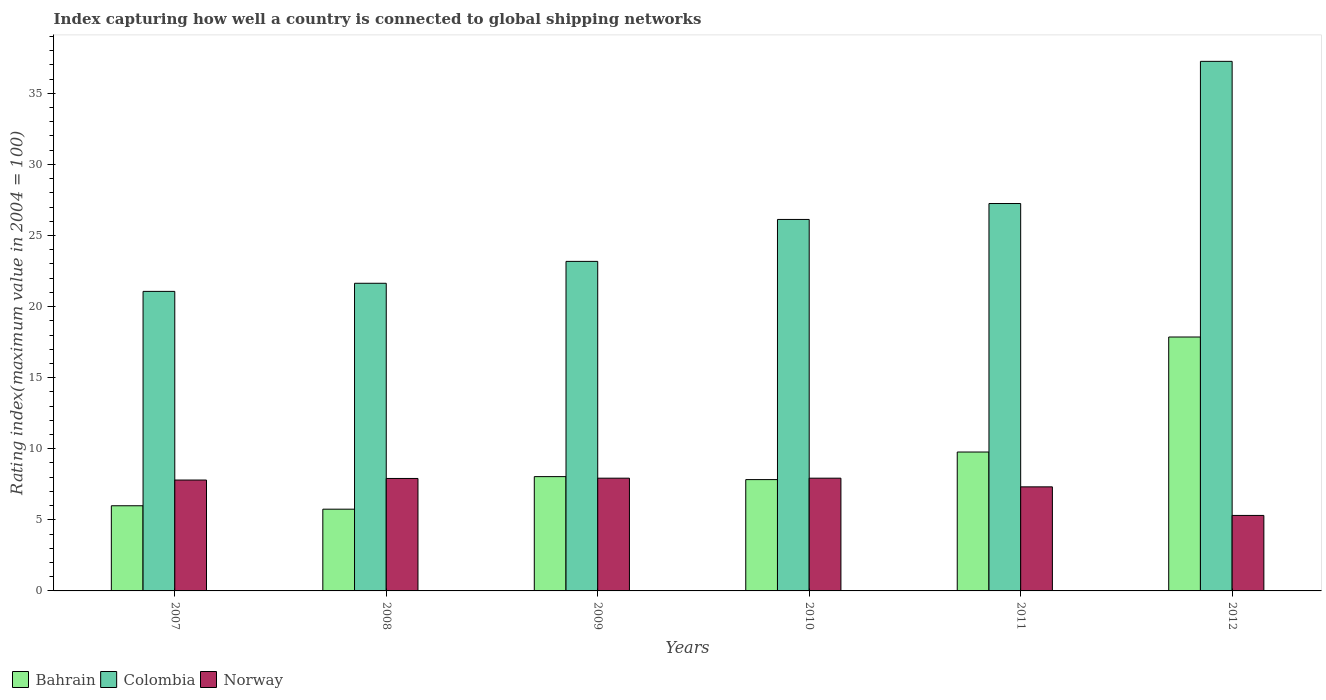How many groups of bars are there?
Your answer should be very brief. 6. Are the number of bars on each tick of the X-axis equal?
Make the answer very short. Yes. How many bars are there on the 3rd tick from the right?
Make the answer very short. 3. What is the label of the 5th group of bars from the left?
Give a very brief answer. 2011. In how many cases, is the number of bars for a given year not equal to the number of legend labels?
Offer a terse response. 0. What is the rating index in Bahrain in 2007?
Keep it short and to the point. 5.99. Across all years, what is the maximum rating index in Bahrain?
Ensure brevity in your answer.  17.86. Across all years, what is the minimum rating index in Bahrain?
Your response must be concise. 5.75. In which year was the rating index in Colombia minimum?
Keep it short and to the point. 2007. What is the total rating index in Colombia in the graph?
Your answer should be compact. 156.52. What is the difference between the rating index in Norway in 2009 and that in 2012?
Your answer should be very brief. 2.62. What is the difference between the rating index in Bahrain in 2007 and the rating index in Norway in 2012?
Your response must be concise. 0.68. What is the average rating index in Colombia per year?
Ensure brevity in your answer.  26.09. In the year 2009, what is the difference between the rating index in Colombia and rating index in Bahrain?
Your answer should be very brief. 15.14. In how many years, is the rating index in Colombia greater than 24?
Provide a short and direct response. 3. What is the ratio of the rating index in Colombia in 2010 to that in 2011?
Make the answer very short. 0.96. Is the rating index in Colombia in 2007 less than that in 2012?
Ensure brevity in your answer.  Yes. What is the difference between the highest and the second highest rating index in Norway?
Ensure brevity in your answer.  0. What is the difference between the highest and the lowest rating index in Colombia?
Give a very brief answer. 16.18. In how many years, is the rating index in Colombia greater than the average rating index in Colombia taken over all years?
Offer a very short reply. 3. Is the sum of the rating index in Colombia in 2008 and 2012 greater than the maximum rating index in Norway across all years?
Your answer should be compact. Yes. How many years are there in the graph?
Your response must be concise. 6. What is the difference between two consecutive major ticks on the Y-axis?
Give a very brief answer. 5. Does the graph contain any zero values?
Your response must be concise. No. Where does the legend appear in the graph?
Provide a short and direct response. Bottom left. What is the title of the graph?
Your response must be concise. Index capturing how well a country is connected to global shipping networks. What is the label or title of the Y-axis?
Give a very brief answer. Rating index(maximum value in 2004 = 100). What is the Rating index(maximum value in 2004 = 100) of Bahrain in 2007?
Make the answer very short. 5.99. What is the Rating index(maximum value in 2004 = 100) of Colombia in 2007?
Offer a terse response. 21.07. What is the Rating index(maximum value in 2004 = 100) in Norway in 2007?
Keep it short and to the point. 7.8. What is the Rating index(maximum value in 2004 = 100) of Bahrain in 2008?
Give a very brief answer. 5.75. What is the Rating index(maximum value in 2004 = 100) of Colombia in 2008?
Offer a very short reply. 21.64. What is the Rating index(maximum value in 2004 = 100) of Norway in 2008?
Keep it short and to the point. 7.91. What is the Rating index(maximum value in 2004 = 100) of Bahrain in 2009?
Give a very brief answer. 8.04. What is the Rating index(maximum value in 2004 = 100) of Colombia in 2009?
Offer a terse response. 23.18. What is the Rating index(maximum value in 2004 = 100) of Norway in 2009?
Your response must be concise. 7.93. What is the Rating index(maximum value in 2004 = 100) of Bahrain in 2010?
Your response must be concise. 7.83. What is the Rating index(maximum value in 2004 = 100) of Colombia in 2010?
Provide a short and direct response. 26.13. What is the Rating index(maximum value in 2004 = 100) of Norway in 2010?
Your response must be concise. 7.93. What is the Rating index(maximum value in 2004 = 100) in Bahrain in 2011?
Ensure brevity in your answer.  9.77. What is the Rating index(maximum value in 2004 = 100) in Colombia in 2011?
Your answer should be compact. 27.25. What is the Rating index(maximum value in 2004 = 100) in Norway in 2011?
Keep it short and to the point. 7.32. What is the Rating index(maximum value in 2004 = 100) in Bahrain in 2012?
Provide a short and direct response. 17.86. What is the Rating index(maximum value in 2004 = 100) of Colombia in 2012?
Your response must be concise. 37.25. What is the Rating index(maximum value in 2004 = 100) in Norway in 2012?
Your answer should be compact. 5.31. Across all years, what is the maximum Rating index(maximum value in 2004 = 100) of Bahrain?
Your answer should be very brief. 17.86. Across all years, what is the maximum Rating index(maximum value in 2004 = 100) in Colombia?
Your answer should be very brief. 37.25. Across all years, what is the maximum Rating index(maximum value in 2004 = 100) in Norway?
Provide a short and direct response. 7.93. Across all years, what is the minimum Rating index(maximum value in 2004 = 100) in Bahrain?
Your response must be concise. 5.75. Across all years, what is the minimum Rating index(maximum value in 2004 = 100) in Colombia?
Make the answer very short. 21.07. Across all years, what is the minimum Rating index(maximum value in 2004 = 100) in Norway?
Give a very brief answer. 5.31. What is the total Rating index(maximum value in 2004 = 100) of Bahrain in the graph?
Your answer should be very brief. 55.24. What is the total Rating index(maximum value in 2004 = 100) of Colombia in the graph?
Provide a short and direct response. 156.52. What is the total Rating index(maximum value in 2004 = 100) of Norway in the graph?
Offer a terse response. 44.2. What is the difference between the Rating index(maximum value in 2004 = 100) of Bahrain in 2007 and that in 2008?
Keep it short and to the point. 0.24. What is the difference between the Rating index(maximum value in 2004 = 100) of Colombia in 2007 and that in 2008?
Ensure brevity in your answer.  -0.57. What is the difference between the Rating index(maximum value in 2004 = 100) in Norway in 2007 and that in 2008?
Provide a short and direct response. -0.11. What is the difference between the Rating index(maximum value in 2004 = 100) in Bahrain in 2007 and that in 2009?
Make the answer very short. -2.05. What is the difference between the Rating index(maximum value in 2004 = 100) in Colombia in 2007 and that in 2009?
Ensure brevity in your answer.  -2.11. What is the difference between the Rating index(maximum value in 2004 = 100) in Norway in 2007 and that in 2009?
Provide a short and direct response. -0.13. What is the difference between the Rating index(maximum value in 2004 = 100) in Bahrain in 2007 and that in 2010?
Your response must be concise. -1.84. What is the difference between the Rating index(maximum value in 2004 = 100) in Colombia in 2007 and that in 2010?
Offer a terse response. -5.06. What is the difference between the Rating index(maximum value in 2004 = 100) of Norway in 2007 and that in 2010?
Keep it short and to the point. -0.13. What is the difference between the Rating index(maximum value in 2004 = 100) in Bahrain in 2007 and that in 2011?
Provide a succinct answer. -3.78. What is the difference between the Rating index(maximum value in 2004 = 100) in Colombia in 2007 and that in 2011?
Keep it short and to the point. -6.18. What is the difference between the Rating index(maximum value in 2004 = 100) in Norway in 2007 and that in 2011?
Provide a short and direct response. 0.48. What is the difference between the Rating index(maximum value in 2004 = 100) of Bahrain in 2007 and that in 2012?
Give a very brief answer. -11.87. What is the difference between the Rating index(maximum value in 2004 = 100) in Colombia in 2007 and that in 2012?
Provide a succinct answer. -16.18. What is the difference between the Rating index(maximum value in 2004 = 100) in Norway in 2007 and that in 2012?
Your answer should be compact. 2.49. What is the difference between the Rating index(maximum value in 2004 = 100) in Bahrain in 2008 and that in 2009?
Your answer should be compact. -2.29. What is the difference between the Rating index(maximum value in 2004 = 100) of Colombia in 2008 and that in 2009?
Provide a short and direct response. -1.54. What is the difference between the Rating index(maximum value in 2004 = 100) of Norway in 2008 and that in 2009?
Your answer should be very brief. -0.02. What is the difference between the Rating index(maximum value in 2004 = 100) in Bahrain in 2008 and that in 2010?
Provide a succinct answer. -2.08. What is the difference between the Rating index(maximum value in 2004 = 100) in Colombia in 2008 and that in 2010?
Give a very brief answer. -4.49. What is the difference between the Rating index(maximum value in 2004 = 100) in Norway in 2008 and that in 2010?
Your answer should be very brief. -0.02. What is the difference between the Rating index(maximum value in 2004 = 100) in Bahrain in 2008 and that in 2011?
Make the answer very short. -4.02. What is the difference between the Rating index(maximum value in 2004 = 100) in Colombia in 2008 and that in 2011?
Your answer should be compact. -5.61. What is the difference between the Rating index(maximum value in 2004 = 100) of Norway in 2008 and that in 2011?
Keep it short and to the point. 0.59. What is the difference between the Rating index(maximum value in 2004 = 100) of Bahrain in 2008 and that in 2012?
Offer a terse response. -12.11. What is the difference between the Rating index(maximum value in 2004 = 100) in Colombia in 2008 and that in 2012?
Your answer should be very brief. -15.61. What is the difference between the Rating index(maximum value in 2004 = 100) of Norway in 2008 and that in 2012?
Provide a succinct answer. 2.6. What is the difference between the Rating index(maximum value in 2004 = 100) in Bahrain in 2009 and that in 2010?
Offer a very short reply. 0.21. What is the difference between the Rating index(maximum value in 2004 = 100) in Colombia in 2009 and that in 2010?
Provide a short and direct response. -2.95. What is the difference between the Rating index(maximum value in 2004 = 100) in Bahrain in 2009 and that in 2011?
Provide a succinct answer. -1.73. What is the difference between the Rating index(maximum value in 2004 = 100) in Colombia in 2009 and that in 2011?
Your answer should be compact. -4.07. What is the difference between the Rating index(maximum value in 2004 = 100) of Norway in 2009 and that in 2011?
Offer a very short reply. 0.61. What is the difference between the Rating index(maximum value in 2004 = 100) of Bahrain in 2009 and that in 2012?
Ensure brevity in your answer.  -9.82. What is the difference between the Rating index(maximum value in 2004 = 100) of Colombia in 2009 and that in 2012?
Provide a succinct answer. -14.07. What is the difference between the Rating index(maximum value in 2004 = 100) in Norway in 2009 and that in 2012?
Offer a very short reply. 2.62. What is the difference between the Rating index(maximum value in 2004 = 100) of Bahrain in 2010 and that in 2011?
Your answer should be very brief. -1.94. What is the difference between the Rating index(maximum value in 2004 = 100) of Colombia in 2010 and that in 2011?
Provide a short and direct response. -1.12. What is the difference between the Rating index(maximum value in 2004 = 100) in Norway in 2010 and that in 2011?
Offer a very short reply. 0.61. What is the difference between the Rating index(maximum value in 2004 = 100) of Bahrain in 2010 and that in 2012?
Your answer should be very brief. -10.03. What is the difference between the Rating index(maximum value in 2004 = 100) in Colombia in 2010 and that in 2012?
Provide a short and direct response. -11.12. What is the difference between the Rating index(maximum value in 2004 = 100) of Norway in 2010 and that in 2012?
Make the answer very short. 2.62. What is the difference between the Rating index(maximum value in 2004 = 100) in Bahrain in 2011 and that in 2012?
Make the answer very short. -8.09. What is the difference between the Rating index(maximum value in 2004 = 100) of Colombia in 2011 and that in 2012?
Ensure brevity in your answer.  -10. What is the difference between the Rating index(maximum value in 2004 = 100) of Norway in 2011 and that in 2012?
Make the answer very short. 2.01. What is the difference between the Rating index(maximum value in 2004 = 100) of Bahrain in 2007 and the Rating index(maximum value in 2004 = 100) of Colombia in 2008?
Your answer should be very brief. -15.65. What is the difference between the Rating index(maximum value in 2004 = 100) of Bahrain in 2007 and the Rating index(maximum value in 2004 = 100) of Norway in 2008?
Provide a short and direct response. -1.92. What is the difference between the Rating index(maximum value in 2004 = 100) of Colombia in 2007 and the Rating index(maximum value in 2004 = 100) of Norway in 2008?
Your answer should be compact. 13.16. What is the difference between the Rating index(maximum value in 2004 = 100) in Bahrain in 2007 and the Rating index(maximum value in 2004 = 100) in Colombia in 2009?
Your answer should be compact. -17.19. What is the difference between the Rating index(maximum value in 2004 = 100) of Bahrain in 2007 and the Rating index(maximum value in 2004 = 100) of Norway in 2009?
Ensure brevity in your answer.  -1.94. What is the difference between the Rating index(maximum value in 2004 = 100) of Colombia in 2007 and the Rating index(maximum value in 2004 = 100) of Norway in 2009?
Your answer should be compact. 13.14. What is the difference between the Rating index(maximum value in 2004 = 100) in Bahrain in 2007 and the Rating index(maximum value in 2004 = 100) in Colombia in 2010?
Offer a terse response. -20.14. What is the difference between the Rating index(maximum value in 2004 = 100) in Bahrain in 2007 and the Rating index(maximum value in 2004 = 100) in Norway in 2010?
Your answer should be compact. -1.94. What is the difference between the Rating index(maximum value in 2004 = 100) of Colombia in 2007 and the Rating index(maximum value in 2004 = 100) of Norway in 2010?
Provide a succinct answer. 13.14. What is the difference between the Rating index(maximum value in 2004 = 100) of Bahrain in 2007 and the Rating index(maximum value in 2004 = 100) of Colombia in 2011?
Keep it short and to the point. -21.26. What is the difference between the Rating index(maximum value in 2004 = 100) of Bahrain in 2007 and the Rating index(maximum value in 2004 = 100) of Norway in 2011?
Ensure brevity in your answer.  -1.33. What is the difference between the Rating index(maximum value in 2004 = 100) in Colombia in 2007 and the Rating index(maximum value in 2004 = 100) in Norway in 2011?
Your answer should be compact. 13.75. What is the difference between the Rating index(maximum value in 2004 = 100) of Bahrain in 2007 and the Rating index(maximum value in 2004 = 100) of Colombia in 2012?
Offer a very short reply. -31.26. What is the difference between the Rating index(maximum value in 2004 = 100) of Bahrain in 2007 and the Rating index(maximum value in 2004 = 100) of Norway in 2012?
Your answer should be compact. 0.68. What is the difference between the Rating index(maximum value in 2004 = 100) in Colombia in 2007 and the Rating index(maximum value in 2004 = 100) in Norway in 2012?
Your answer should be very brief. 15.76. What is the difference between the Rating index(maximum value in 2004 = 100) in Bahrain in 2008 and the Rating index(maximum value in 2004 = 100) in Colombia in 2009?
Provide a short and direct response. -17.43. What is the difference between the Rating index(maximum value in 2004 = 100) in Bahrain in 2008 and the Rating index(maximum value in 2004 = 100) in Norway in 2009?
Provide a short and direct response. -2.18. What is the difference between the Rating index(maximum value in 2004 = 100) of Colombia in 2008 and the Rating index(maximum value in 2004 = 100) of Norway in 2009?
Offer a terse response. 13.71. What is the difference between the Rating index(maximum value in 2004 = 100) in Bahrain in 2008 and the Rating index(maximum value in 2004 = 100) in Colombia in 2010?
Offer a terse response. -20.38. What is the difference between the Rating index(maximum value in 2004 = 100) in Bahrain in 2008 and the Rating index(maximum value in 2004 = 100) in Norway in 2010?
Offer a terse response. -2.18. What is the difference between the Rating index(maximum value in 2004 = 100) of Colombia in 2008 and the Rating index(maximum value in 2004 = 100) of Norway in 2010?
Your response must be concise. 13.71. What is the difference between the Rating index(maximum value in 2004 = 100) in Bahrain in 2008 and the Rating index(maximum value in 2004 = 100) in Colombia in 2011?
Keep it short and to the point. -21.5. What is the difference between the Rating index(maximum value in 2004 = 100) of Bahrain in 2008 and the Rating index(maximum value in 2004 = 100) of Norway in 2011?
Your answer should be compact. -1.57. What is the difference between the Rating index(maximum value in 2004 = 100) of Colombia in 2008 and the Rating index(maximum value in 2004 = 100) of Norway in 2011?
Provide a succinct answer. 14.32. What is the difference between the Rating index(maximum value in 2004 = 100) in Bahrain in 2008 and the Rating index(maximum value in 2004 = 100) in Colombia in 2012?
Give a very brief answer. -31.5. What is the difference between the Rating index(maximum value in 2004 = 100) in Bahrain in 2008 and the Rating index(maximum value in 2004 = 100) in Norway in 2012?
Offer a terse response. 0.44. What is the difference between the Rating index(maximum value in 2004 = 100) in Colombia in 2008 and the Rating index(maximum value in 2004 = 100) in Norway in 2012?
Make the answer very short. 16.33. What is the difference between the Rating index(maximum value in 2004 = 100) in Bahrain in 2009 and the Rating index(maximum value in 2004 = 100) in Colombia in 2010?
Make the answer very short. -18.09. What is the difference between the Rating index(maximum value in 2004 = 100) in Bahrain in 2009 and the Rating index(maximum value in 2004 = 100) in Norway in 2010?
Your answer should be very brief. 0.11. What is the difference between the Rating index(maximum value in 2004 = 100) of Colombia in 2009 and the Rating index(maximum value in 2004 = 100) of Norway in 2010?
Give a very brief answer. 15.25. What is the difference between the Rating index(maximum value in 2004 = 100) in Bahrain in 2009 and the Rating index(maximum value in 2004 = 100) in Colombia in 2011?
Your answer should be compact. -19.21. What is the difference between the Rating index(maximum value in 2004 = 100) in Bahrain in 2009 and the Rating index(maximum value in 2004 = 100) in Norway in 2011?
Offer a very short reply. 0.72. What is the difference between the Rating index(maximum value in 2004 = 100) of Colombia in 2009 and the Rating index(maximum value in 2004 = 100) of Norway in 2011?
Offer a very short reply. 15.86. What is the difference between the Rating index(maximum value in 2004 = 100) of Bahrain in 2009 and the Rating index(maximum value in 2004 = 100) of Colombia in 2012?
Give a very brief answer. -29.21. What is the difference between the Rating index(maximum value in 2004 = 100) of Bahrain in 2009 and the Rating index(maximum value in 2004 = 100) of Norway in 2012?
Give a very brief answer. 2.73. What is the difference between the Rating index(maximum value in 2004 = 100) of Colombia in 2009 and the Rating index(maximum value in 2004 = 100) of Norway in 2012?
Offer a terse response. 17.87. What is the difference between the Rating index(maximum value in 2004 = 100) of Bahrain in 2010 and the Rating index(maximum value in 2004 = 100) of Colombia in 2011?
Keep it short and to the point. -19.42. What is the difference between the Rating index(maximum value in 2004 = 100) of Bahrain in 2010 and the Rating index(maximum value in 2004 = 100) of Norway in 2011?
Offer a very short reply. 0.51. What is the difference between the Rating index(maximum value in 2004 = 100) of Colombia in 2010 and the Rating index(maximum value in 2004 = 100) of Norway in 2011?
Ensure brevity in your answer.  18.81. What is the difference between the Rating index(maximum value in 2004 = 100) in Bahrain in 2010 and the Rating index(maximum value in 2004 = 100) in Colombia in 2012?
Keep it short and to the point. -29.42. What is the difference between the Rating index(maximum value in 2004 = 100) in Bahrain in 2010 and the Rating index(maximum value in 2004 = 100) in Norway in 2012?
Give a very brief answer. 2.52. What is the difference between the Rating index(maximum value in 2004 = 100) of Colombia in 2010 and the Rating index(maximum value in 2004 = 100) of Norway in 2012?
Make the answer very short. 20.82. What is the difference between the Rating index(maximum value in 2004 = 100) in Bahrain in 2011 and the Rating index(maximum value in 2004 = 100) in Colombia in 2012?
Provide a succinct answer. -27.48. What is the difference between the Rating index(maximum value in 2004 = 100) in Bahrain in 2011 and the Rating index(maximum value in 2004 = 100) in Norway in 2012?
Make the answer very short. 4.46. What is the difference between the Rating index(maximum value in 2004 = 100) in Colombia in 2011 and the Rating index(maximum value in 2004 = 100) in Norway in 2012?
Give a very brief answer. 21.94. What is the average Rating index(maximum value in 2004 = 100) in Bahrain per year?
Your answer should be compact. 9.21. What is the average Rating index(maximum value in 2004 = 100) of Colombia per year?
Give a very brief answer. 26.09. What is the average Rating index(maximum value in 2004 = 100) in Norway per year?
Give a very brief answer. 7.37. In the year 2007, what is the difference between the Rating index(maximum value in 2004 = 100) of Bahrain and Rating index(maximum value in 2004 = 100) of Colombia?
Offer a terse response. -15.08. In the year 2007, what is the difference between the Rating index(maximum value in 2004 = 100) in Bahrain and Rating index(maximum value in 2004 = 100) in Norway?
Your answer should be compact. -1.81. In the year 2007, what is the difference between the Rating index(maximum value in 2004 = 100) in Colombia and Rating index(maximum value in 2004 = 100) in Norway?
Provide a succinct answer. 13.27. In the year 2008, what is the difference between the Rating index(maximum value in 2004 = 100) of Bahrain and Rating index(maximum value in 2004 = 100) of Colombia?
Your answer should be very brief. -15.89. In the year 2008, what is the difference between the Rating index(maximum value in 2004 = 100) of Bahrain and Rating index(maximum value in 2004 = 100) of Norway?
Your answer should be compact. -2.16. In the year 2008, what is the difference between the Rating index(maximum value in 2004 = 100) of Colombia and Rating index(maximum value in 2004 = 100) of Norway?
Provide a succinct answer. 13.73. In the year 2009, what is the difference between the Rating index(maximum value in 2004 = 100) of Bahrain and Rating index(maximum value in 2004 = 100) of Colombia?
Make the answer very short. -15.14. In the year 2009, what is the difference between the Rating index(maximum value in 2004 = 100) in Bahrain and Rating index(maximum value in 2004 = 100) in Norway?
Provide a short and direct response. 0.11. In the year 2009, what is the difference between the Rating index(maximum value in 2004 = 100) in Colombia and Rating index(maximum value in 2004 = 100) in Norway?
Your answer should be very brief. 15.25. In the year 2010, what is the difference between the Rating index(maximum value in 2004 = 100) in Bahrain and Rating index(maximum value in 2004 = 100) in Colombia?
Your response must be concise. -18.3. In the year 2010, what is the difference between the Rating index(maximum value in 2004 = 100) in Bahrain and Rating index(maximum value in 2004 = 100) in Norway?
Keep it short and to the point. -0.1. In the year 2010, what is the difference between the Rating index(maximum value in 2004 = 100) of Colombia and Rating index(maximum value in 2004 = 100) of Norway?
Your answer should be very brief. 18.2. In the year 2011, what is the difference between the Rating index(maximum value in 2004 = 100) of Bahrain and Rating index(maximum value in 2004 = 100) of Colombia?
Ensure brevity in your answer.  -17.48. In the year 2011, what is the difference between the Rating index(maximum value in 2004 = 100) in Bahrain and Rating index(maximum value in 2004 = 100) in Norway?
Provide a succinct answer. 2.45. In the year 2011, what is the difference between the Rating index(maximum value in 2004 = 100) in Colombia and Rating index(maximum value in 2004 = 100) in Norway?
Offer a very short reply. 19.93. In the year 2012, what is the difference between the Rating index(maximum value in 2004 = 100) of Bahrain and Rating index(maximum value in 2004 = 100) of Colombia?
Offer a terse response. -19.39. In the year 2012, what is the difference between the Rating index(maximum value in 2004 = 100) of Bahrain and Rating index(maximum value in 2004 = 100) of Norway?
Your response must be concise. 12.55. In the year 2012, what is the difference between the Rating index(maximum value in 2004 = 100) of Colombia and Rating index(maximum value in 2004 = 100) of Norway?
Provide a short and direct response. 31.94. What is the ratio of the Rating index(maximum value in 2004 = 100) in Bahrain in 2007 to that in 2008?
Provide a succinct answer. 1.04. What is the ratio of the Rating index(maximum value in 2004 = 100) of Colombia in 2007 to that in 2008?
Your answer should be very brief. 0.97. What is the ratio of the Rating index(maximum value in 2004 = 100) in Norway in 2007 to that in 2008?
Give a very brief answer. 0.99. What is the ratio of the Rating index(maximum value in 2004 = 100) of Bahrain in 2007 to that in 2009?
Your answer should be compact. 0.74. What is the ratio of the Rating index(maximum value in 2004 = 100) in Colombia in 2007 to that in 2009?
Ensure brevity in your answer.  0.91. What is the ratio of the Rating index(maximum value in 2004 = 100) of Norway in 2007 to that in 2009?
Give a very brief answer. 0.98. What is the ratio of the Rating index(maximum value in 2004 = 100) in Bahrain in 2007 to that in 2010?
Your response must be concise. 0.77. What is the ratio of the Rating index(maximum value in 2004 = 100) of Colombia in 2007 to that in 2010?
Offer a terse response. 0.81. What is the ratio of the Rating index(maximum value in 2004 = 100) of Norway in 2007 to that in 2010?
Provide a short and direct response. 0.98. What is the ratio of the Rating index(maximum value in 2004 = 100) of Bahrain in 2007 to that in 2011?
Ensure brevity in your answer.  0.61. What is the ratio of the Rating index(maximum value in 2004 = 100) of Colombia in 2007 to that in 2011?
Your answer should be compact. 0.77. What is the ratio of the Rating index(maximum value in 2004 = 100) in Norway in 2007 to that in 2011?
Make the answer very short. 1.07. What is the ratio of the Rating index(maximum value in 2004 = 100) in Bahrain in 2007 to that in 2012?
Provide a succinct answer. 0.34. What is the ratio of the Rating index(maximum value in 2004 = 100) in Colombia in 2007 to that in 2012?
Offer a terse response. 0.57. What is the ratio of the Rating index(maximum value in 2004 = 100) of Norway in 2007 to that in 2012?
Your answer should be very brief. 1.47. What is the ratio of the Rating index(maximum value in 2004 = 100) of Bahrain in 2008 to that in 2009?
Your answer should be very brief. 0.72. What is the ratio of the Rating index(maximum value in 2004 = 100) of Colombia in 2008 to that in 2009?
Your answer should be compact. 0.93. What is the ratio of the Rating index(maximum value in 2004 = 100) of Norway in 2008 to that in 2009?
Ensure brevity in your answer.  1. What is the ratio of the Rating index(maximum value in 2004 = 100) in Bahrain in 2008 to that in 2010?
Your response must be concise. 0.73. What is the ratio of the Rating index(maximum value in 2004 = 100) in Colombia in 2008 to that in 2010?
Your response must be concise. 0.83. What is the ratio of the Rating index(maximum value in 2004 = 100) in Norway in 2008 to that in 2010?
Make the answer very short. 1. What is the ratio of the Rating index(maximum value in 2004 = 100) of Bahrain in 2008 to that in 2011?
Give a very brief answer. 0.59. What is the ratio of the Rating index(maximum value in 2004 = 100) in Colombia in 2008 to that in 2011?
Ensure brevity in your answer.  0.79. What is the ratio of the Rating index(maximum value in 2004 = 100) in Norway in 2008 to that in 2011?
Give a very brief answer. 1.08. What is the ratio of the Rating index(maximum value in 2004 = 100) of Bahrain in 2008 to that in 2012?
Ensure brevity in your answer.  0.32. What is the ratio of the Rating index(maximum value in 2004 = 100) in Colombia in 2008 to that in 2012?
Provide a succinct answer. 0.58. What is the ratio of the Rating index(maximum value in 2004 = 100) of Norway in 2008 to that in 2012?
Offer a terse response. 1.49. What is the ratio of the Rating index(maximum value in 2004 = 100) of Bahrain in 2009 to that in 2010?
Your answer should be compact. 1.03. What is the ratio of the Rating index(maximum value in 2004 = 100) of Colombia in 2009 to that in 2010?
Your answer should be compact. 0.89. What is the ratio of the Rating index(maximum value in 2004 = 100) of Norway in 2009 to that in 2010?
Ensure brevity in your answer.  1. What is the ratio of the Rating index(maximum value in 2004 = 100) of Bahrain in 2009 to that in 2011?
Your answer should be compact. 0.82. What is the ratio of the Rating index(maximum value in 2004 = 100) in Colombia in 2009 to that in 2011?
Give a very brief answer. 0.85. What is the ratio of the Rating index(maximum value in 2004 = 100) in Norway in 2009 to that in 2011?
Your answer should be very brief. 1.08. What is the ratio of the Rating index(maximum value in 2004 = 100) of Bahrain in 2009 to that in 2012?
Make the answer very short. 0.45. What is the ratio of the Rating index(maximum value in 2004 = 100) of Colombia in 2009 to that in 2012?
Ensure brevity in your answer.  0.62. What is the ratio of the Rating index(maximum value in 2004 = 100) of Norway in 2009 to that in 2012?
Ensure brevity in your answer.  1.49. What is the ratio of the Rating index(maximum value in 2004 = 100) in Bahrain in 2010 to that in 2011?
Your answer should be compact. 0.8. What is the ratio of the Rating index(maximum value in 2004 = 100) of Colombia in 2010 to that in 2011?
Keep it short and to the point. 0.96. What is the ratio of the Rating index(maximum value in 2004 = 100) in Bahrain in 2010 to that in 2012?
Your answer should be very brief. 0.44. What is the ratio of the Rating index(maximum value in 2004 = 100) of Colombia in 2010 to that in 2012?
Give a very brief answer. 0.7. What is the ratio of the Rating index(maximum value in 2004 = 100) of Norway in 2010 to that in 2012?
Offer a very short reply. 1.49. What is the ratio of the Rating index(maximum value in 2004 = 100) of Bahrain in 2011 to that in 2012?
Offer a terse response. 0.55. What is the ratio of the Rating index(maximum value in 2004 = 100) in Colombia in 2011 to that in 2012?
Provide a short and direct response. 0.73. What is the ratio of the Rating index(maximum value in 2004 = 100) in Norway in 2011 to that in 2012?
Ensure brevity in your answer.  1.38. What is the difference between the highest and the second highest Rating index(maximum value in 2004 = 100) in Bahrain?
Keep it short and to the point. 8.09. What is the difference between the highest and the second highest Rating index(maximum value in 2004 = 100) in Colombia?
Ensure brevity in your answer.  10. What is the difference between the highest and the second highest Rating index(maximum value in 2004 = 100) of Norway?
Your response must be concise. 0. What is the difference between the highest and the lowest Rating index(maximum value in 2004 = 100) of Bahrain?
Offer a very short reply. 12.11. What is the difference between the highest and the lowest Rating index(maximum value in 2004 = 100) of Colombia?
Offer a very short reply. 16.18. What is the difference between the highest and the lowest Rating index(maximum value in 2004 = 100) of Norway?
Ensure brevity in your answer.  2.62. 